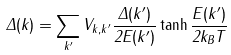Convert formula to latex. <formula><loc_0><loc_0><loc_500><loc_500>\Delta ( { k } ) = \sum _ { k ^ { \prime } } V _ { k , k ^ { \prime } } \frac { \Delta ( { k ^ { \prime } } ) } { 2 E ( { k ^ { \prime } } ) } \tanh \frac { E ( { k ^ { \prime } } ) } { 2 k _ { B } T }</formula> 